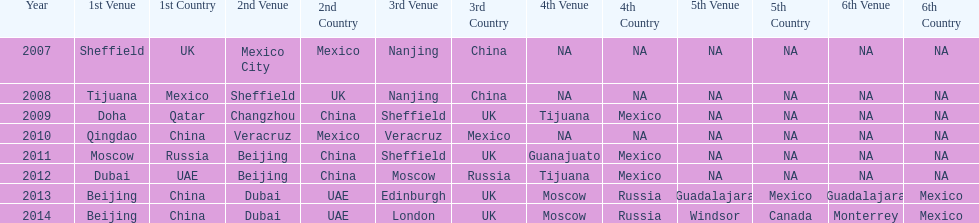What was the last year where tijuana was a venue? 2012. 